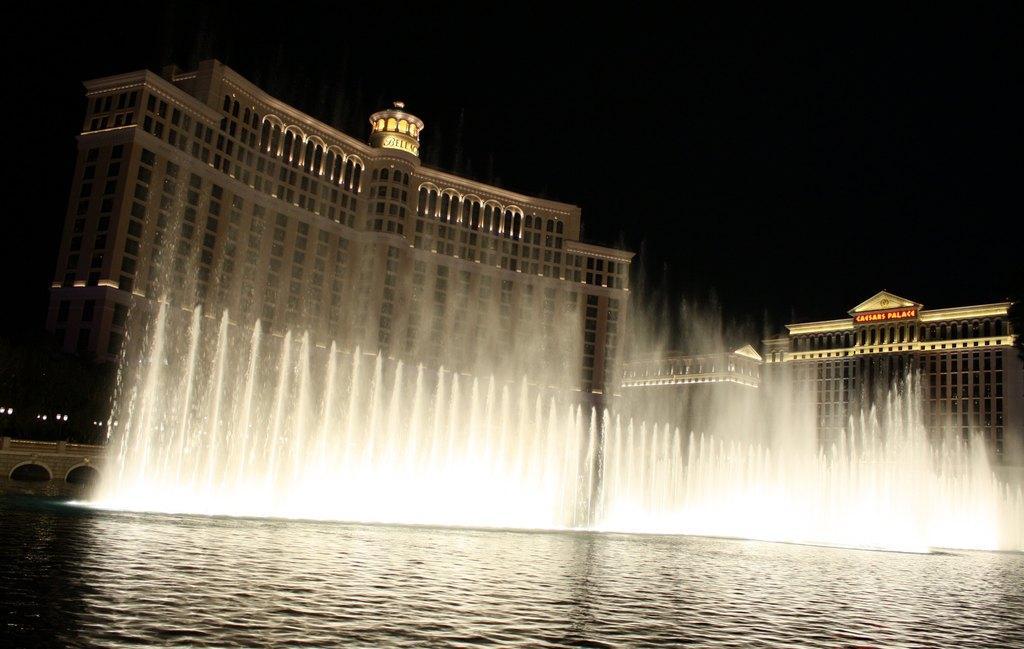How would you summarize this image in a sentence or two? There is a water fountain and this is water. In the background there are buildings and this is sky. 